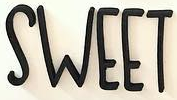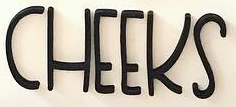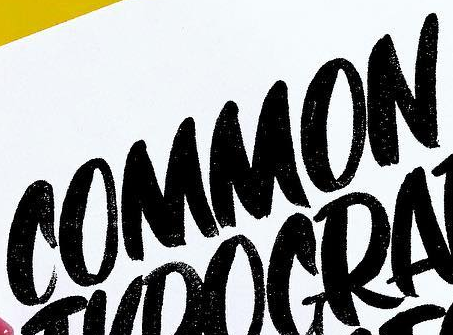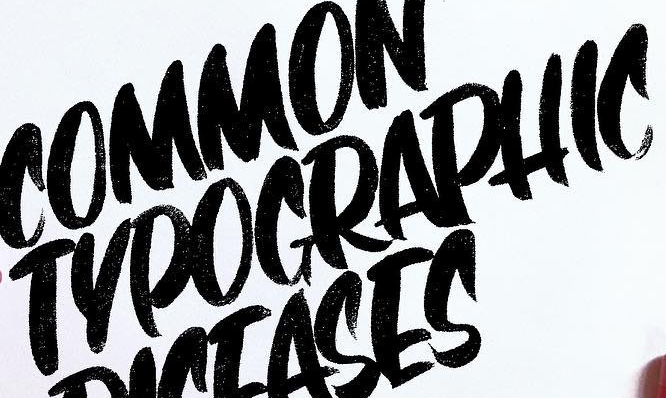Read the text content from these images in order, separated by a semicolon. SWEET; CHEEKS; COMMON; TYPOGRAPHIC 